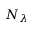Convert formula to latex. <formula><loc_0><loc_0><loc_500><loc_500>N _ { \lambda }</formula> 